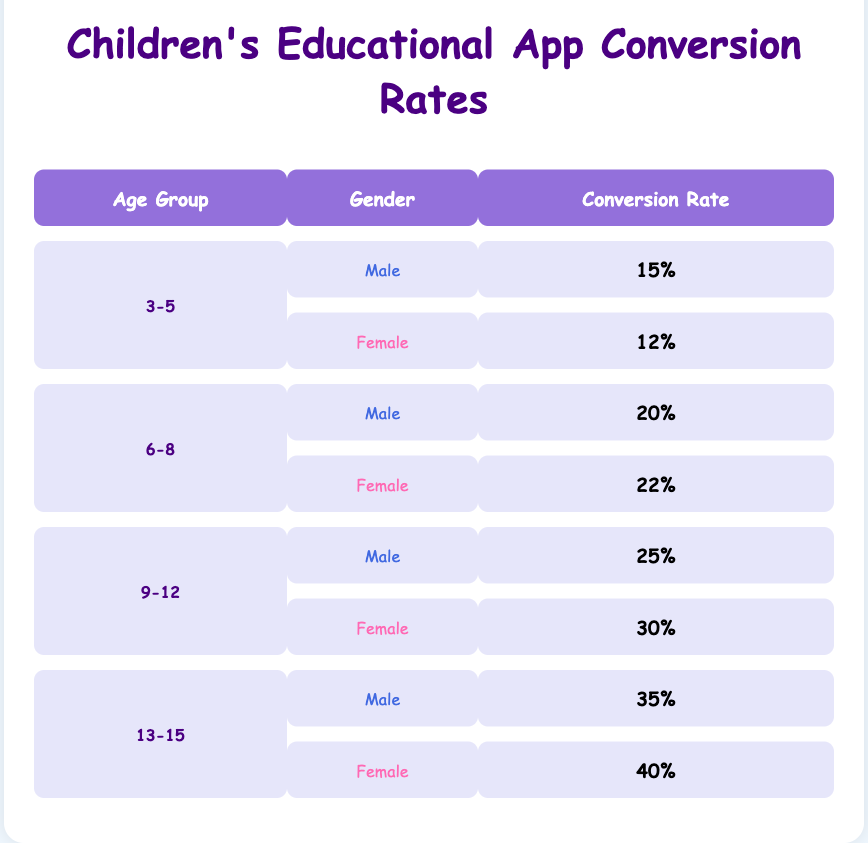What is the conversion rate for males in the 3-5 age group? The table shows that the conversion rate for males in the 3-5 age group is 15%.
Answer: 15% What is the conversion rate for females in the 6-8 age group? According to the table, the conversion rate for females aged 6-8 is 22%.
Answer: 22% Which age group has the highest conversion rate for females? Analyzing the table, we see that the 13-15 age group has the highest conversion rate for females at 40%.
Answer: 40% What is the average conversion rate for males across all age groups? To find the average, we add the male conversion rates: 15 + 20 + 25 + 35 = 95, then divide by the number of age groups (4), resulting in 95 / 4 = 23.75%.
Answer: 23.75% Is the conversion rate for females in the 9-12 age group higher than that of males in the same age group? By comparing values in the table, females in the 9-12 age group (30%) do have a higher conversion rate than males (25%).
Answer: Yes In the 6-8 age group, what is the percentage difference in conversion rates between males and females? The difference can be calculated by subtracting the male rate (20%) from the female rate (22%), resulting in 22 - 20 = 2%.
Answer: 2% What is the total conversion rate for all age groups of females? To calculate the total, we add the conversion rates for females: 12 + 22 + 30 + 40 = 104%.
Answer: 104% Which gender has a higher conversion rate in the 9-12 age group? The table indicates that the conversion rate for females (30%) is higher compared to males (25%) in the 9-12 age group.
Answer: Female For the 3-5 age group, how does the conversion rate for females compare to that of males? In the table, females have a conversion rate of 12%, while males have 15%. Since 15% > 12%, males have a higher conversion rate.
Answer: Males have a higher conversion rate 